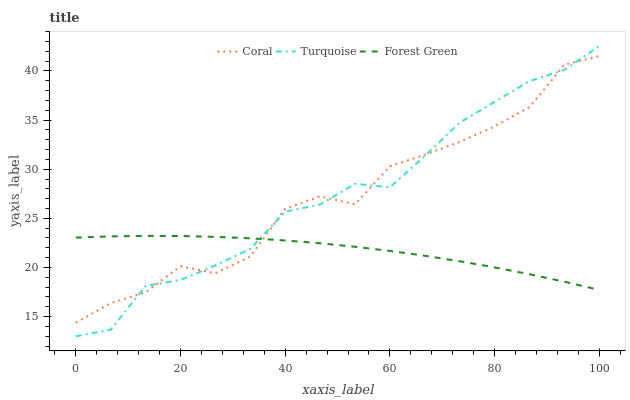Does Forest Green have the minimum area under the curve?
Answer yes or no. Yes. Does Turquoise have the maximum area under the curve?
Answer yes or no. Yes. Does Coral have the minimum area under the curve?
Answer yes or no. No. Does Coral have the maximum area under the curve?
Answer yes or no. No. Is Forest Green the smoothest?
Answer yes or no. Yes. Is Coral the roughest?
Answer yes or no. Yes. Is Turquoise the smoothest?
Answer yes or no. No. Is Turquoise the roughest?
Answer yes or no. No. Does Turquoise have the lowest value?
Answer yes or no. Yes. Does Coral have the lowest value?
Answer yes or no. No. Does Turquoise have the highest value?
Answer yes or no. Yes. Does Coral have the highest value?
Answer yes or no. No. Does Forest Green intersect Coral?
Answer yes or no. Yes. Is Forest Green less than Coral?
Answer yes or no. No. Is Forest Green greater than Coral?
Answer yes or no. No. 